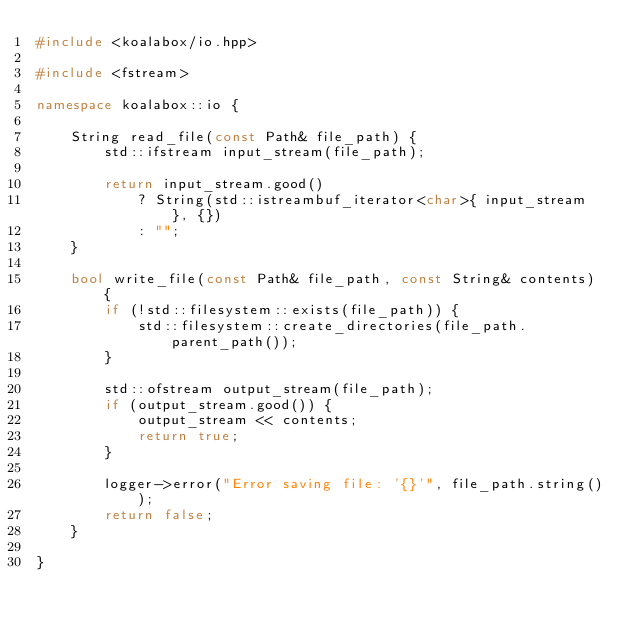Convert code to text. <code><loc_0><loc_0><loc_500><loc_500><_C++_>#include <koalabox/io.hpp>

#include <fstream>

namespace koalabox::io {

    String read_file(const Path& file_path) {
        std::ifstream input_stream(file_path);

        return input_stream.good()
            ? String(std::istreambuf_iterator<char>{ input_stream }, {})
            : "";
    }

    bool write_file(const Path& file_path, const String& contents) {
        if (!std::filesystem::exists(file_path)) {
            std::filesystem::create_directories(file_path.parent_path());
        }

        std::ofstream output_stream(file_path);
        if (output_stream.good()) {
            output_stream << contents;
            return true;
        }

        logger->error("Error saving file: '{}'", file_path.string());
        return false;
    }

}
</code> 